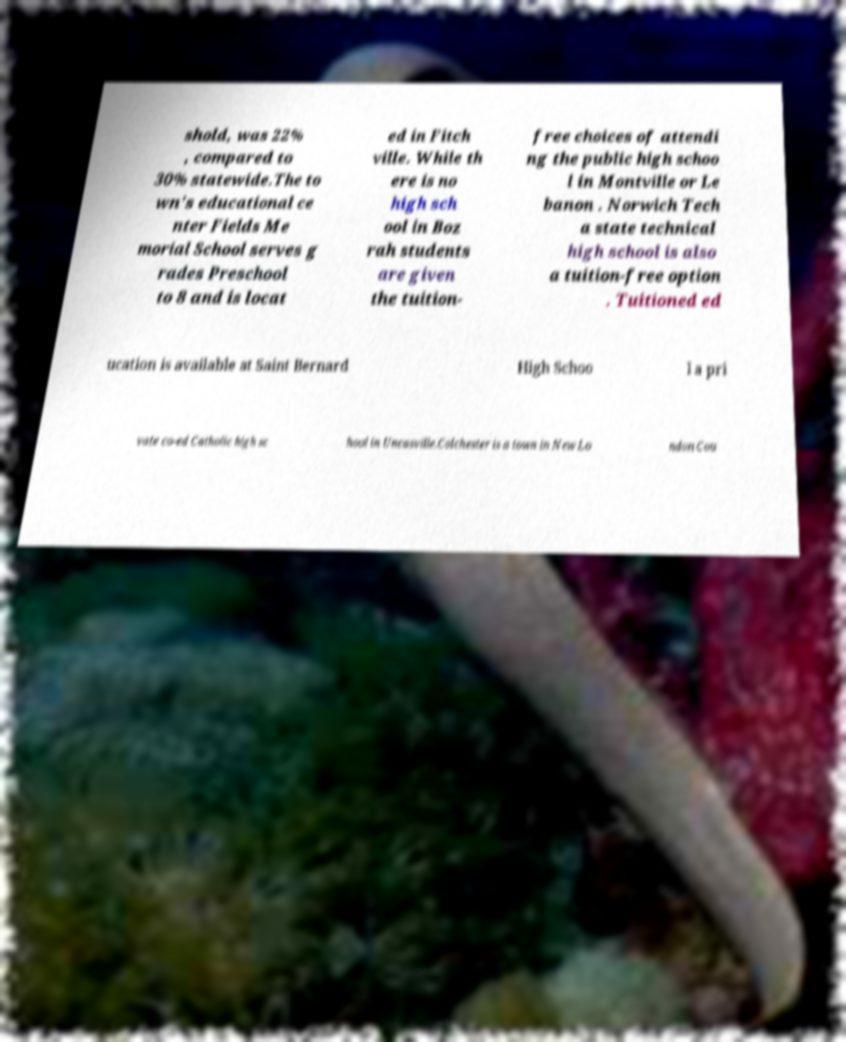For documentation purposes, I need the text within this image transcribed. Could you provide that? shold, was 22% , compared to 30% statewide.The to wn's educational ce nter Fields Me morial School serves g rades Preschool to 8 and is locat ed in Fitch ville. While th ere is no high sch ool in Boz rah students are given the tuition- free choices of attendi ng the public high schoo l in Montville or Le banon . Norwich Tech a state technical high school is also a tuition-free option . Tuitioned ed ucation is available at Saint Bernard High Schoo l a pri vate co-ed Catholic high sc hool in Uncasville.Colchester is a town in New Lo ndon Cou 